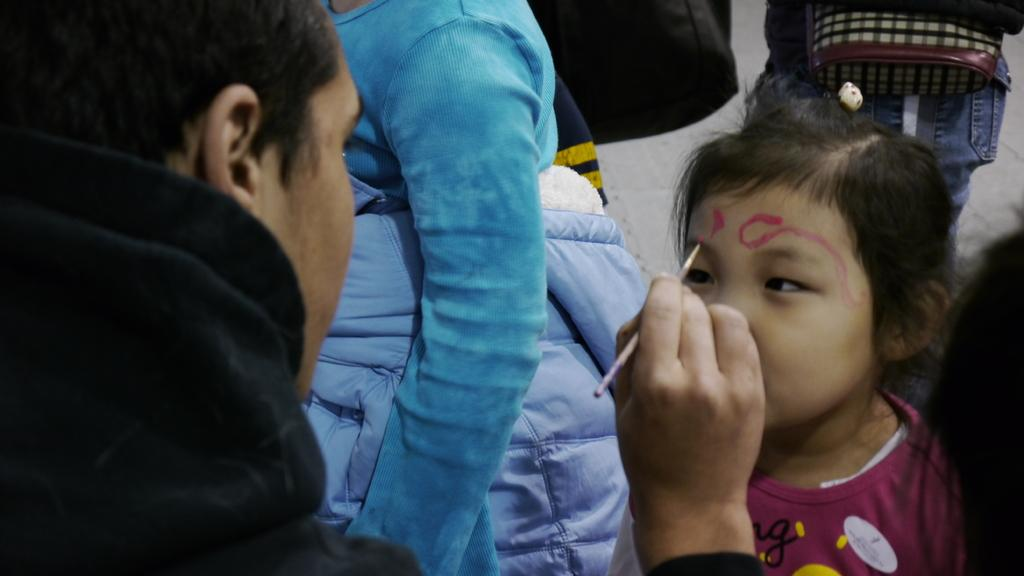What can be seen in the image involving a group of people? There is a group of people in the image, and a man is painting on a girl's face. Can you describe the man in the image? The man in the image is holding a brush. What is the man doing with the brush? The man is using the brush to paint on a girl's face. Is the girl part of the group of people? Yes, the girl is part of the group of people. How does the man plan to turn the girl into a patch in the image? There is no indication in the image that the man is trying to turn the girl into a patch. The man is simply painting on the girl's face. 